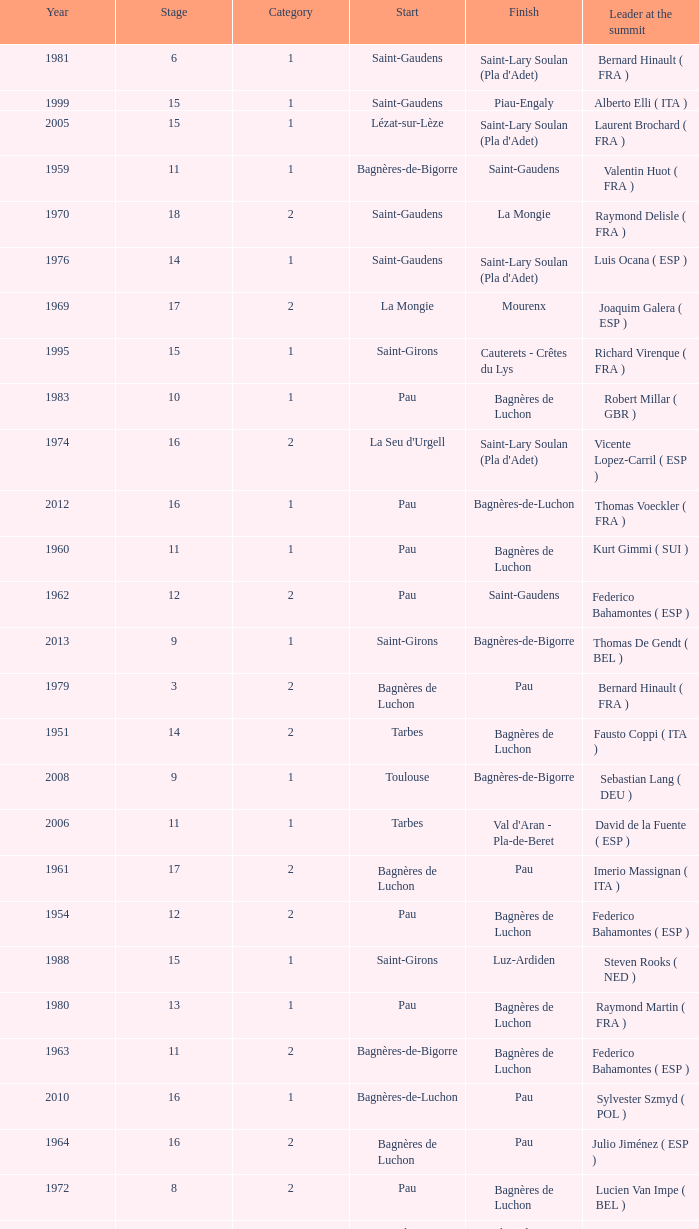What category was in 1964? 2.0. 